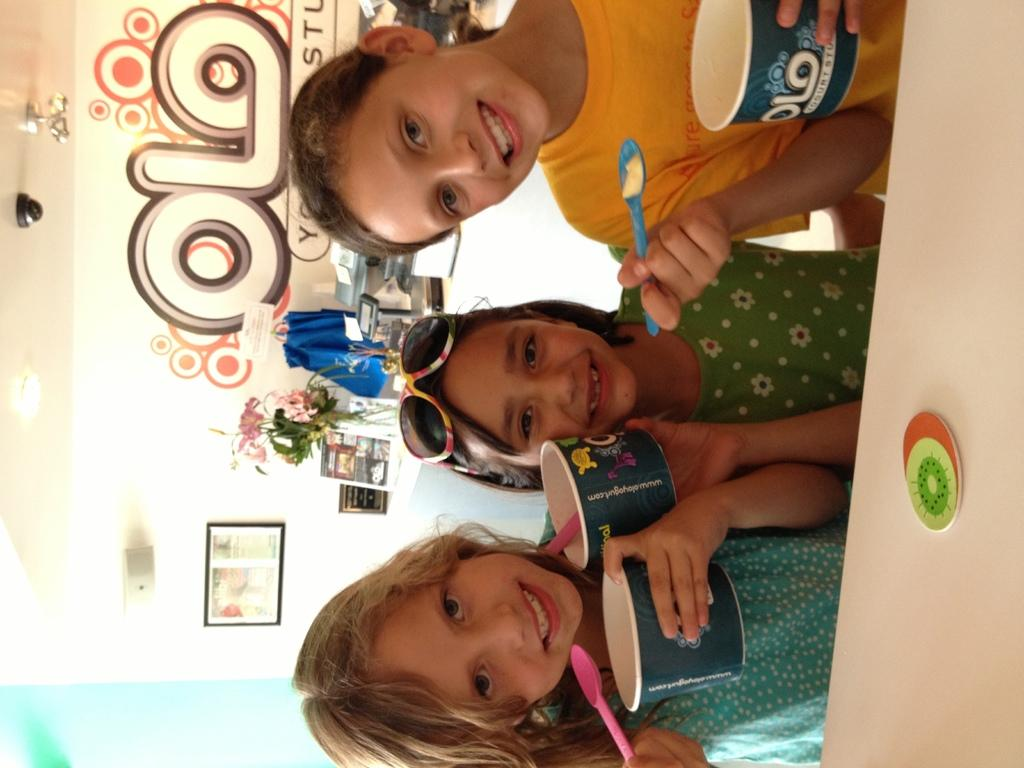How many children are present in the image? There are three children in the image. What are the children holding in their hands? The children are holding cups in their hands. What expressions do the children have on their faces? The children are looking and smiling in the image. What can be seen in the background of the image? There is a wall, a frame, flowers with a flower vase, and other objects visible in the background of the image. What type of insect is sitting on the judge's shoulder in the image? There is no judge or insect present in the image. 